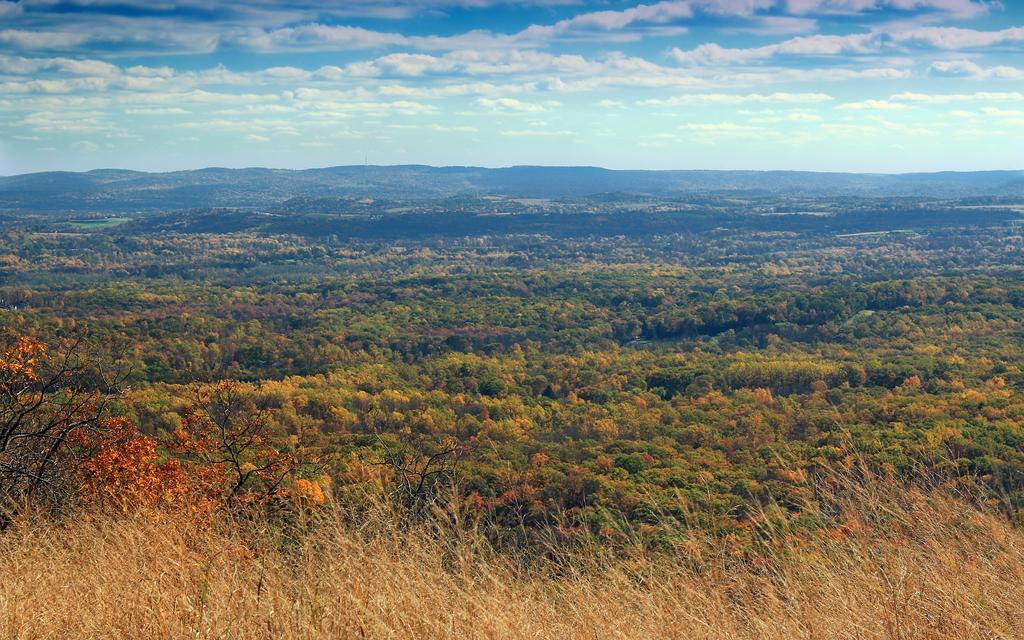Describe this image in one or two sentences. This image consists of many trees and plants. At the bottom, there is dry grass. In the background, we can see the mountains. At the top, there are clouds in the sky. 